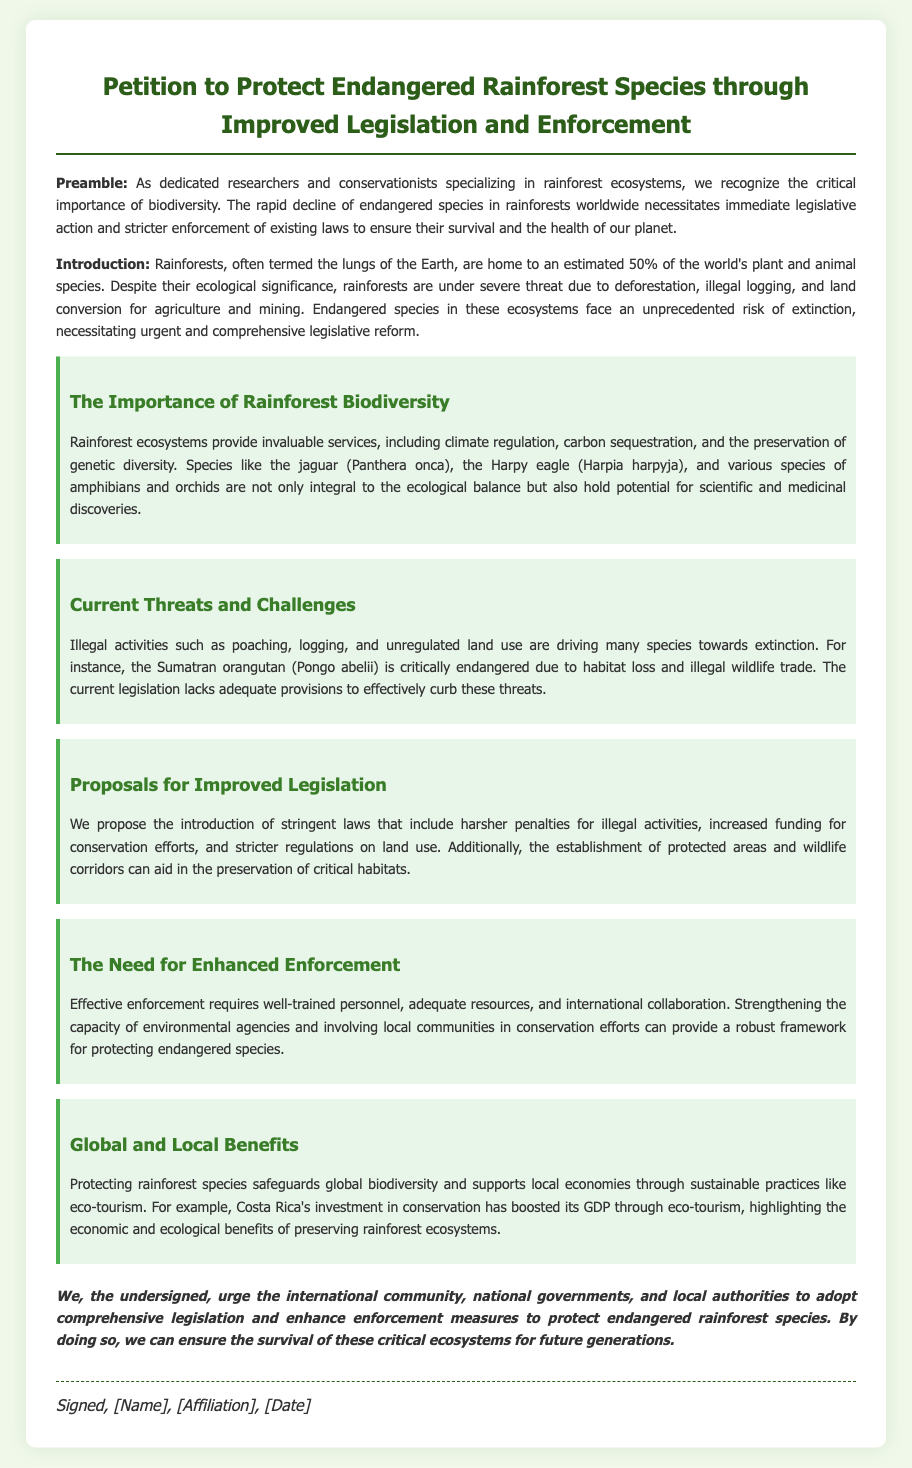What is the title of the petition? The title of the petition is clearly stated at the top of the document.
Answer: Petition to Protect Endangered Rainforest Species through Improved Legislation and Enforcement What percentage of the world's species are found in rainforests? The document states that rainforests are home to an estimated 50% of the world's plant and animal species.
Answer: 50% Which species is mentioned as critically endangered due to habitat loss? The document provides an example of a species that is critically endangered, specifically due to habitat loss.
Answer: Sumatran orangutan What is one proposed action for improving legislation? The document lists several proposals for improving legislation regarding endangered species.
Answer: Harsher penalties for illegal activities What country is cited as an example of successful conservation boosting GDP? The document mentions a specific country's investment in conservation that has positively affected its economy.
Answer: Costa Rica What is a key benefit of protecting rainforest species? The document outlines several benefits of protecting endangered species in rainforest ecosystems.
Answer: Global biodiversity What is emphasized as essential for effective enforcement? The document identifies crucial components necessary for the enforcement of wildlife protection laws.
Answer: Well-trained personnel What are wildlife corridors intended to aid? The document mentions the establishment of specific areas for the purpose of conservation.
Answer: Preservation of critical habitats 